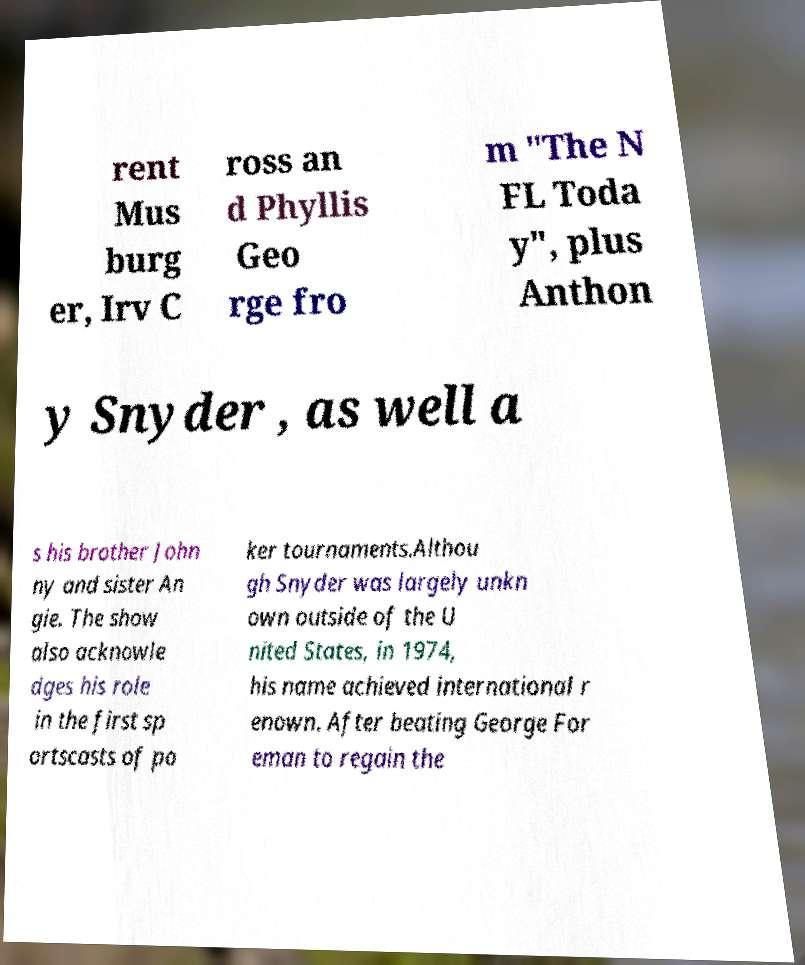I need the written content from this picture converted into text. Can you do that? rent Mus burg er, Irv C ross an d Phyllis Geo rge fro m "The N FL Toda y", plus Anthon y Snyder , as well a s his brother John ny and sister An gie. The show also acknowle dges his role in the first sp ortscasts of po ker tournaments.Althou gh Snyder was largely unkn own outside of the U nited States, in 1974, his name achieved international r enown. After beating George For eman to regain the 